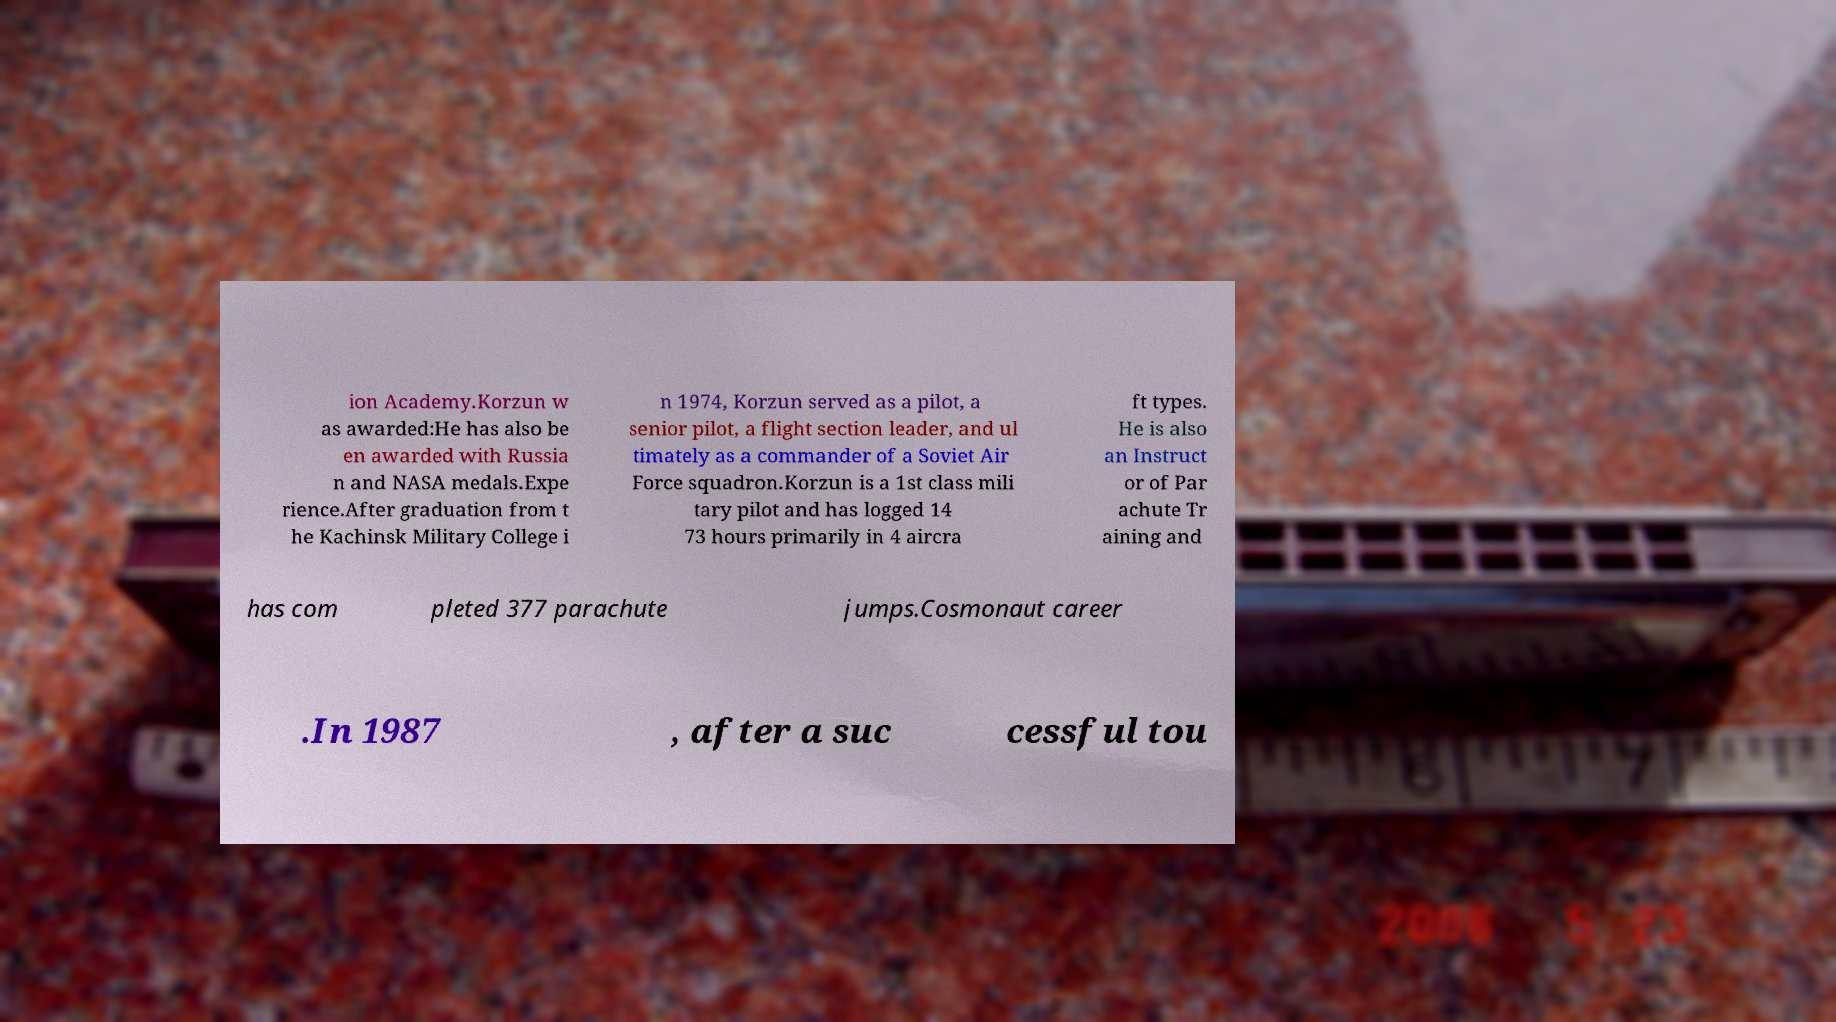Could you assist in decoding the text presented in this image and type it out clearly? ion Academy.Korzun w as awarded:He has also be en awarded with Russia n and NASA medals.Expe rience.After graduation from t he Kachinsk Military College i n 1974, Korzun served as a pilot, a senior pilot, a flight section leader, and ul timately as a commander of a Soviet Air Force squadron.Korzun is a 1st class mili tary pilot and has logged 14 73 hours primarily in 4 aircra ft types. He is also an Instruct or of Par achute Tr aining and has com pleted 377 parachute jumps.Cosmonaut career .In 1987 , after a suc cessful tou 